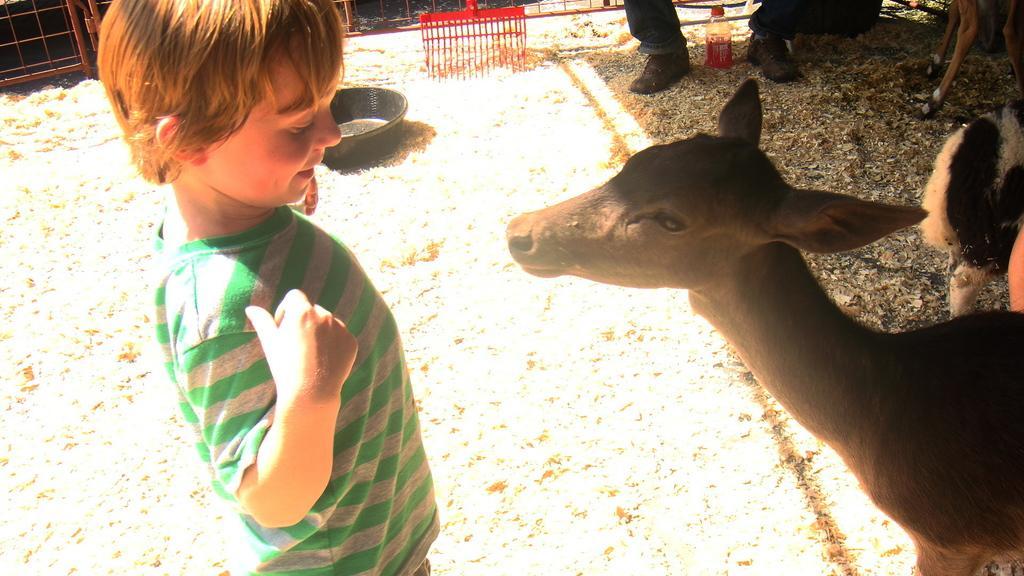Can you describe this image briefly? In this image in the foreground there is an animal,boy, in the background there is a bowl , sweeper, bottle kept between legs of persons and animal legs visible at the top, in the top left there is a fence, on the right side there is might be an animal. 